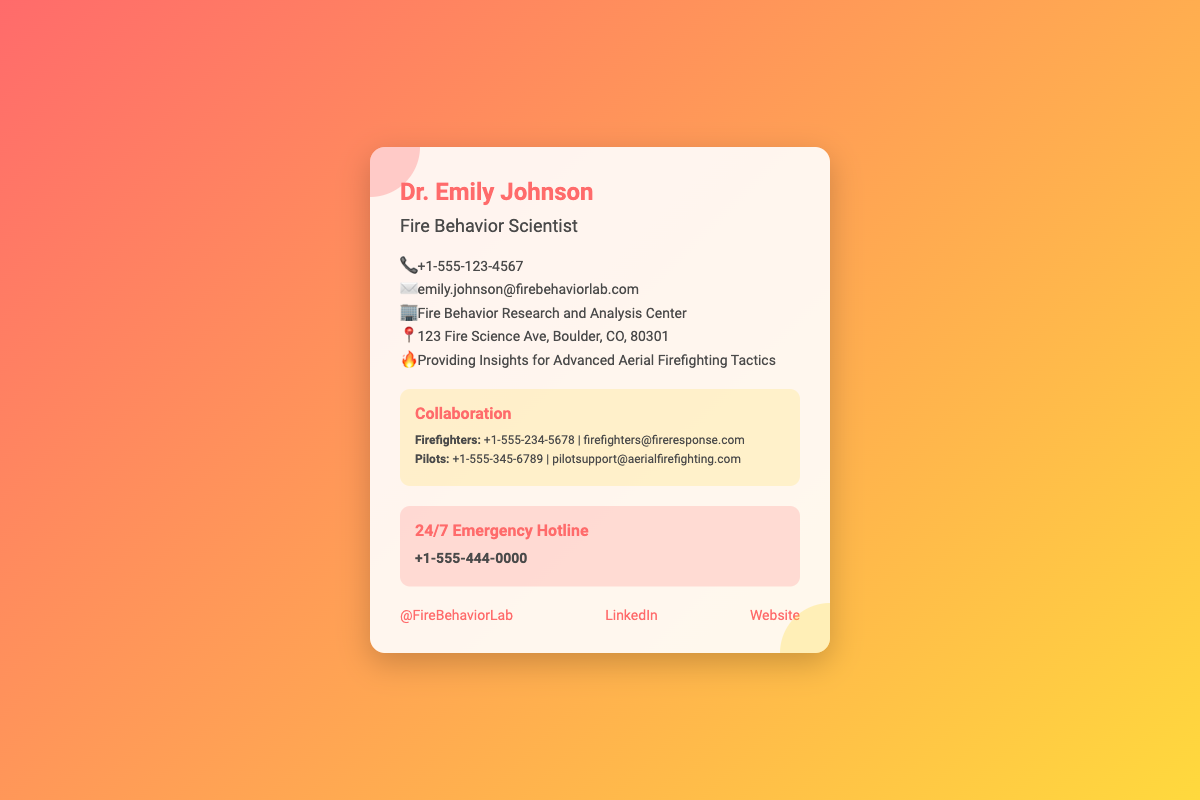What is Dr. Emily Johnson's profession? Dr. Emily Johnson is identified as a "Fire Behavior Scientist" in the document.
Answer: Fire Behavior Scientist What is the phone number for the 24/7 Emergency Hotline? The Hotline number is directly stated in the emergency section of the card.
Answer: +1-555-444-0000 Where is the Fire Behavior Research and Analysis Center located? The address is explicitly listed in the info section of the card.
Answer: 123 Fire Science Ave, Boulder, CO, 80301 Who can be contacted for firefighter collaboration? The contact information for firefighters is provided in the collaboration section.
Answer: +1-555-234-5678 What is the email address for Dr. Emily Johnson? Emily Johnson's email is provided in the contact information section.
Answer: emily.johnson@firebehaviorlab.com What type of tactics does Dr. Emily Johnson provide insights on? The document specifies insights on "Advanced Aerial Firefighting Tactics."
Answer: Advanced Aerial Firefighting Tactics Which social media platform is linked for the Fire Behavior Lab? The document mentions a Twitter handle in the social section.
Answer: @FireBehaviorLab What organizational role does the contact for "Pilots" have? The document identifies the role relating to pilots in the collaboration section.
Answer: Pilots How many contact methods are listed for collaboration? The collaboration section lists two contact methods for different groups.
Answer: Two 